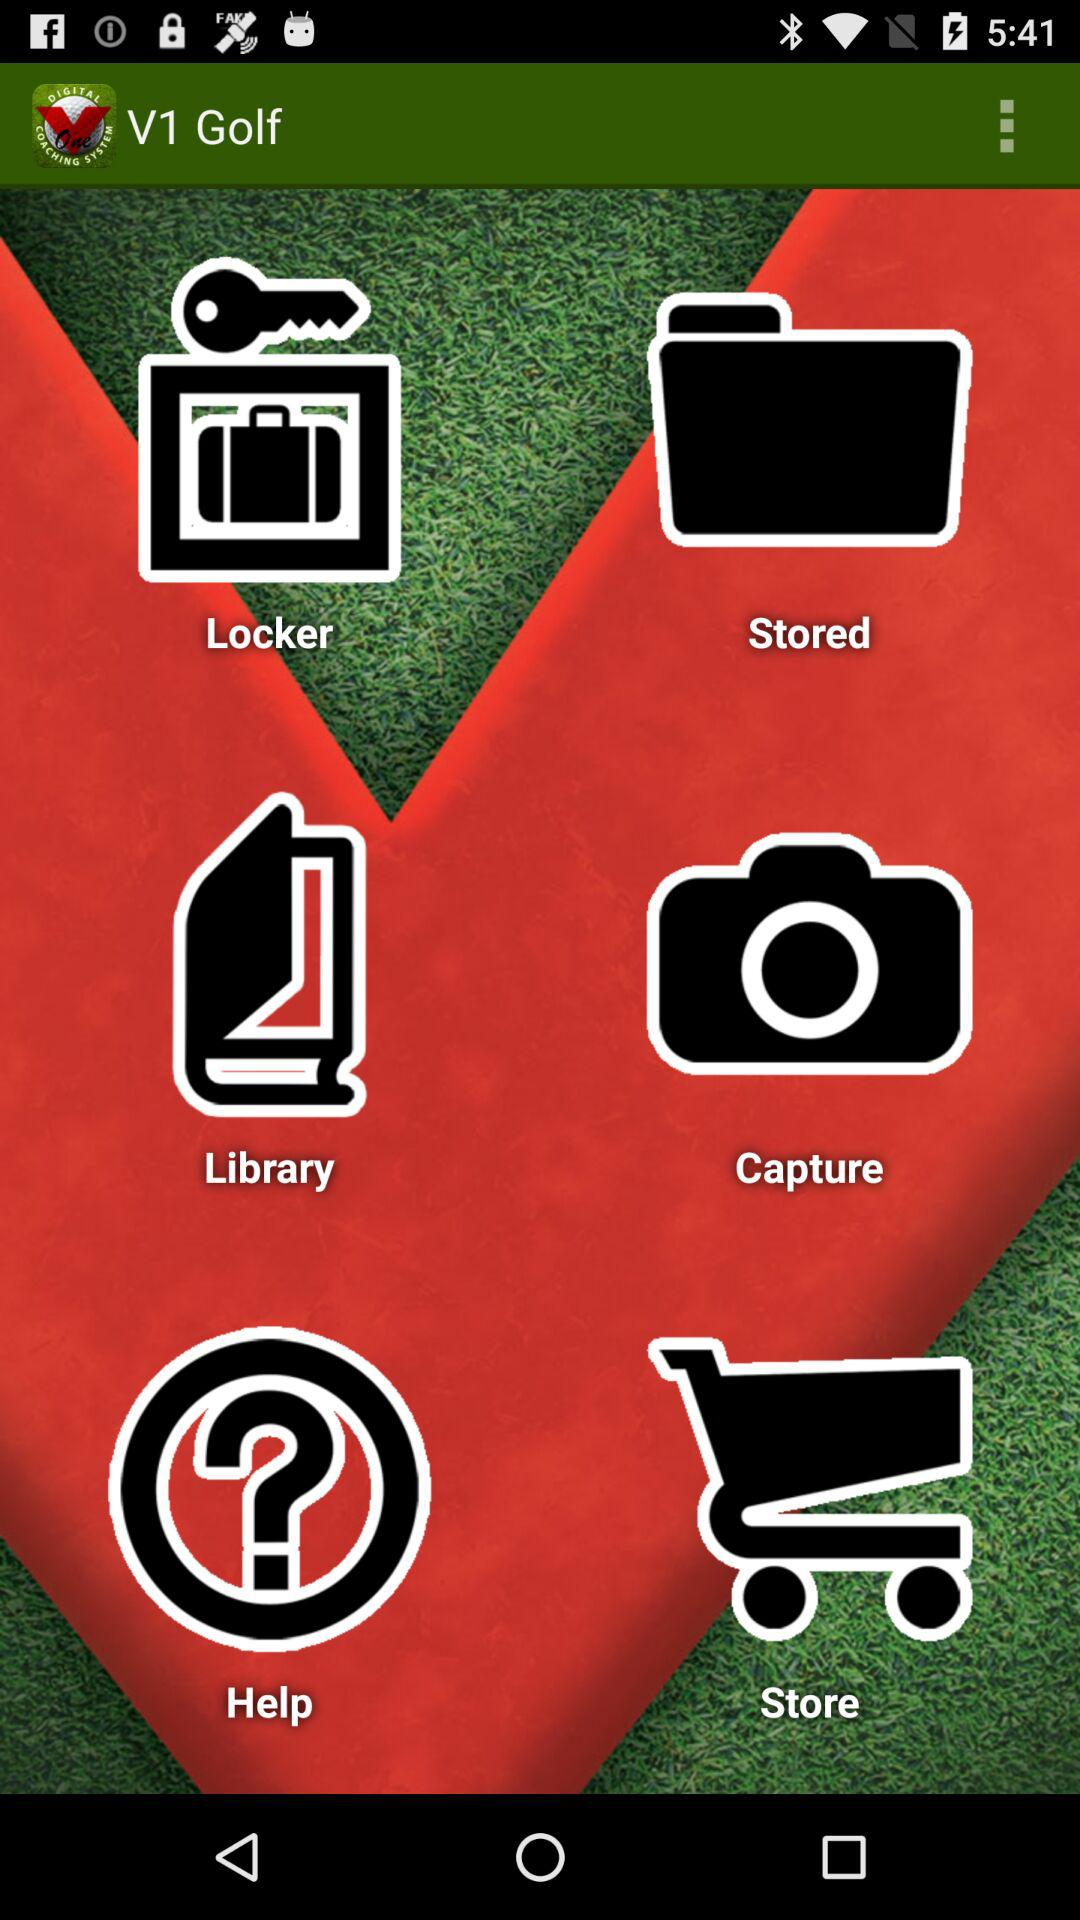What is the application name? The application name is "V1 Golf". 